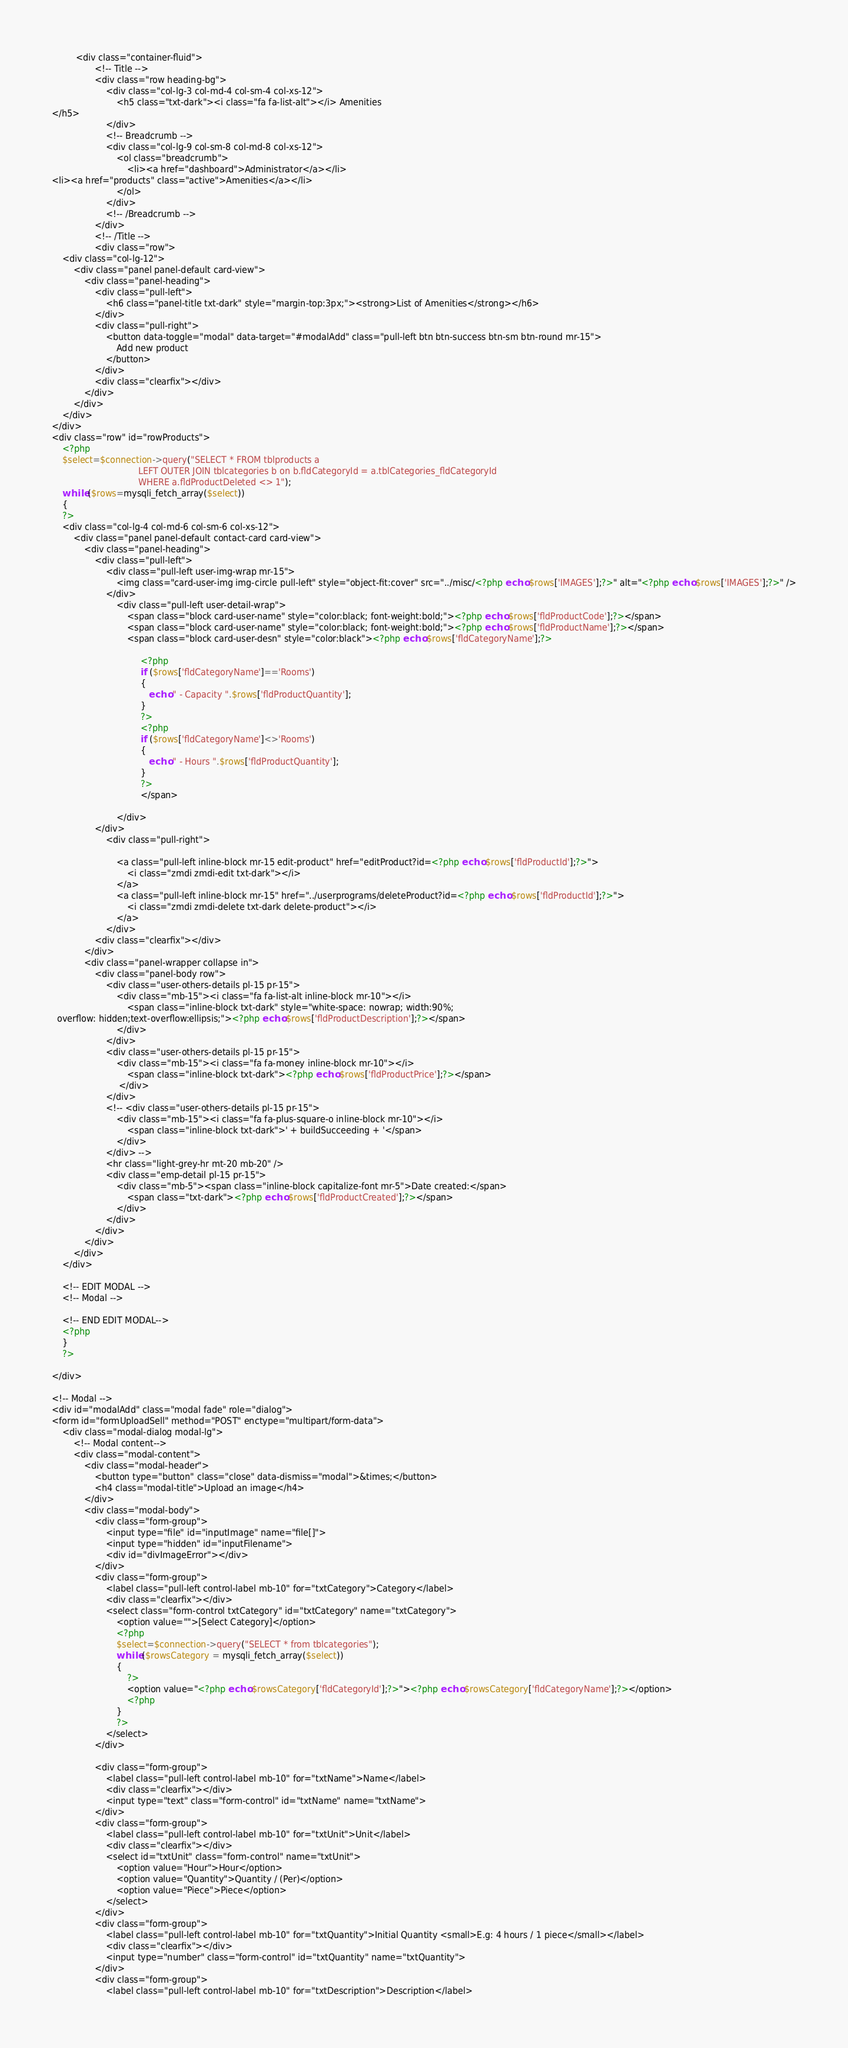<code> <loc_0><loc_0><loc_500><loc_500><_PHP_>         <div class="container-fluid">
                <!-- Title -->
                <div class="row heading-bg">
                    <div class="col-lg-3 col-md-4 col-sm-4 col-xs-12">
                        <h5 class="txt-dark"><i class="fa fa-list-alt"></i> Amenities
</h5>
                    </div>
                    <!-- Breadcrumb -->
                    <div class="col-lg-9 col-sm-8 col-md-8 col-xs-12">
                        <ol class="breadcrumb">
                            <li><a href="dashboard">Administrator</a></li>
<li><a href="products" class="active">Amenities</a></li>
                        </ol>
                    </div>
                    <!-- /Breadcrumb -->
                </div>
                <!-- /Title -->
                <div class="row">
    <div class="col-lg-12">
        <div class="panel panel-default card-view">
            <div class="panel-heading">
                <div class="pull-left">
                    <h6 class="panel-title txt-dark" style="margin-top:3px;"><strong>List of Amenities</strong></h6>
                </div>
                <div class="pull-right">
                    <button data-toggle="modal" data-target="#modalAdd" class="pull-left btn btn-success btn-sm btn-round mr-15">
                        Add new product
                    </button>
                </div>
                <div class="clearfix"></div>
            </div>
        </div>
    </div>
</div>
<div class="row" id="rowProducts">
    <?php 
    $select=$connection->query("SELECT * FROM tblproducts a 
                                LEFT OUTER JOIN tblcategories b on b.fldCategoryId = a.tblCategories_fldCategoryId
                                WHERE a.fldProductDeleted <> 1");
    while ($rows=mysqli_fetch_array($select))
    {
    ?>
    <div class="col-lg-4 col-md-6 col-sm-6 col-xs-12">
        <div class="panel panel-default contact-card card-view">
            <div class="panel-heading">
                <div class="pull-left">
                    <div class="pull-left user-img-wrap mr-15">
                        <img class="card-user-img img-circle pull-left" style="object-fit:cover" src="../misc/<?php echo $rows['IMAGES'];?>" alt="<?php echo $rows['IMAGES'];?>" />
                    </div>
                        <div class="pull-left user-detail-wrap">
                            <span class="block card-user-name" style="color:black; font-weight:bold;"><?php echo $rows['fldProductCode'];?></span>
                            <span class="block card-user-name" style="color:black; font-weight:bold;"><?php echo $rows['fldProductName'];?></span>
                            <span class="block card-user-desn" style="color:black"><?php echo $rows['fldCategoryName'];?>
                                 
                                 <?php
                                 if ($rows['fldCategoryName']=='Rooms')
                                 {
                                    echo " - Capacity ".$rows['fldProductQuantity'];
                                 }
                                 ?>
                                 <?php
                                 if ($rows['fldCategoryName']<>'Rooms')
                                 {
                                    echo " - Hours ".$rows['fldProductQuantity'];
                                 }
                                 ?>
                                 </span>
                           
                        </div>
                </div>
                    <div class="pull-right"> 

                        <a class="pull-left inline-block mr-15 edit-product" href="editProduct?id=<?php echo $rows['fldProductId'];?>"> 
                            <i class="zmdi zmdi-edit txt-dark"></i>
                        </a>
                        <a class="pull-left inline-block mr-15" href="../userprograms/deleteProduct?id=<?php echo $rows['fldProductId'];?>">
                            <i class="zmdi zmdi-delete txt-dark delete-product"></i>
                        </a>
                    </div>
                <div class="clearfix"></div>
            </div>
            <div class="panel-wrapper collapse in">
                <div class="panel-body row">
                    <div class="user-others-details pl-15 pr-15">
                        <div class="mb-15"><i class="fa fa-list-alt inline-block mr-10"></i>
                            <span class="inline-block txt-dark" style="white-space: nowrap; width:90%; 
  overflow: hidden;text-overflow:ellipsis;"><?php echo $rows['fldProductDescription'];?></span>
                        </div>
                    </div>
                    <div class="user-others-details pl-15 pr-15">
                        <div class="mb-15"><i class="fa fa-money inline-block mr-10"></i>
                            <span class="inline-block txt-dark"><?php echo $rows['fldProductPrice'];?></span>
                         </div>
                    </div>
                    <!-- <div class="user-others-details pl-15 pr-15">
                        <div class="mb-15"><i class="fa fa-plus-square-o inline-block mr-10"></i>
                            <span class="inline-block txt-dark">' + buildSucceeding + '</span>
                        </div>
                    </div> -->
                    <hr class="light-grey-hr mt-20 mb-20" />
                    <div class="emp-detail pl-15 pr-15">
                        <div class="mb-5"><span class="inline-block capitalize-font mr-5">Date created:</span>
                            <span class="txt-dark"><?php echo $rows['fldProductCreated'];?></span>
                        </div>
                    </div>
                </div>
            </div>
        </div>
    </div>

    <!-- EDIT MODAL -->
    <!-- Modal -->

    <!-- END EDIT MODAL-->
    <?php
    }
    ?>

</div>

<!-- Modal -->
<div id="modalAdd" class="modal fade" role="dialog">
<form id="formUploadSell" method="POST" enctype="multipart/form-data">
    <div class="modal-dialog modal-lg">
        <!-- Modal content-->
        <div class="modal-content">
            <div class="modal-header">
                <button type="button" class="close" data-dismiss="modal">&times;</button>
                <h4 class="modal-title">Upload an image</h4>
            </div>
            <div class="modal-body">
                <div class="form-group">
                    <input type="file" id="inputImage" name="file[]">
                    <input type="hidden" id="inputFilename">
                    <div id="divImageError"></div>
                </div>
                <div class="form-group">
                    <label class="pull-left control-label mb-10" for="txtCategory">Category</label>
                    <div class="clearfix"></div>
                    <select class="form-control txtCategory" id="txtCategory" name="txtCategory">
                        <option value="">[Select Category]</option>
                        <?php 
                        $select=$connection->query("SELECT * from tblcategories");
                        while ($rowsCategory = mysqli_fetch_array($select))
                        {
                            ?>
                            <option value="<?php echo $rowsCategory['fldCategoryId'];?>"><?php echo $rowsCategory['fldCategoryName'];?></option>
                            <?php
                        }
                        ?>
                    </select>
                </div>
                
                <div class="form-group">
                    <label class="pull-left control-label mb-10" for="txtName">Name</label>
                    <div class="clearfix"></div>
                    <input type="text" class="form-control" id="txtName" name="txtName">
                </div>
                <div class="form-group">
                    <label class="pull-left control-label mb-10" for="txtUnit">Unit</label>
                    <div class="clearfix"></div>
                    <select id="txtUnit" class="form-control" name="txtUnit">
                        <option value="Hour">Hour</option>
                        <option value="Quantity">Quantity / (Per)</option>
                        <option value="Piece">Piece</option>
                    </select>
                </div>
                <div class="form-group">
                    <label class="pull-left control-label mb-10" for="txtQuantity">Initial Quantity <small>E.g: 4 hours / 1 piece</small></label>
                    <div class="clearfix"></div>
                    <input type="number" class="form-control" id="txtQuantity" name="txtQuantity">
                </div>
                <div class="form-group">
                    <label class="pull-left control-label mb-10" for="txtDescription">Description</label></code> 